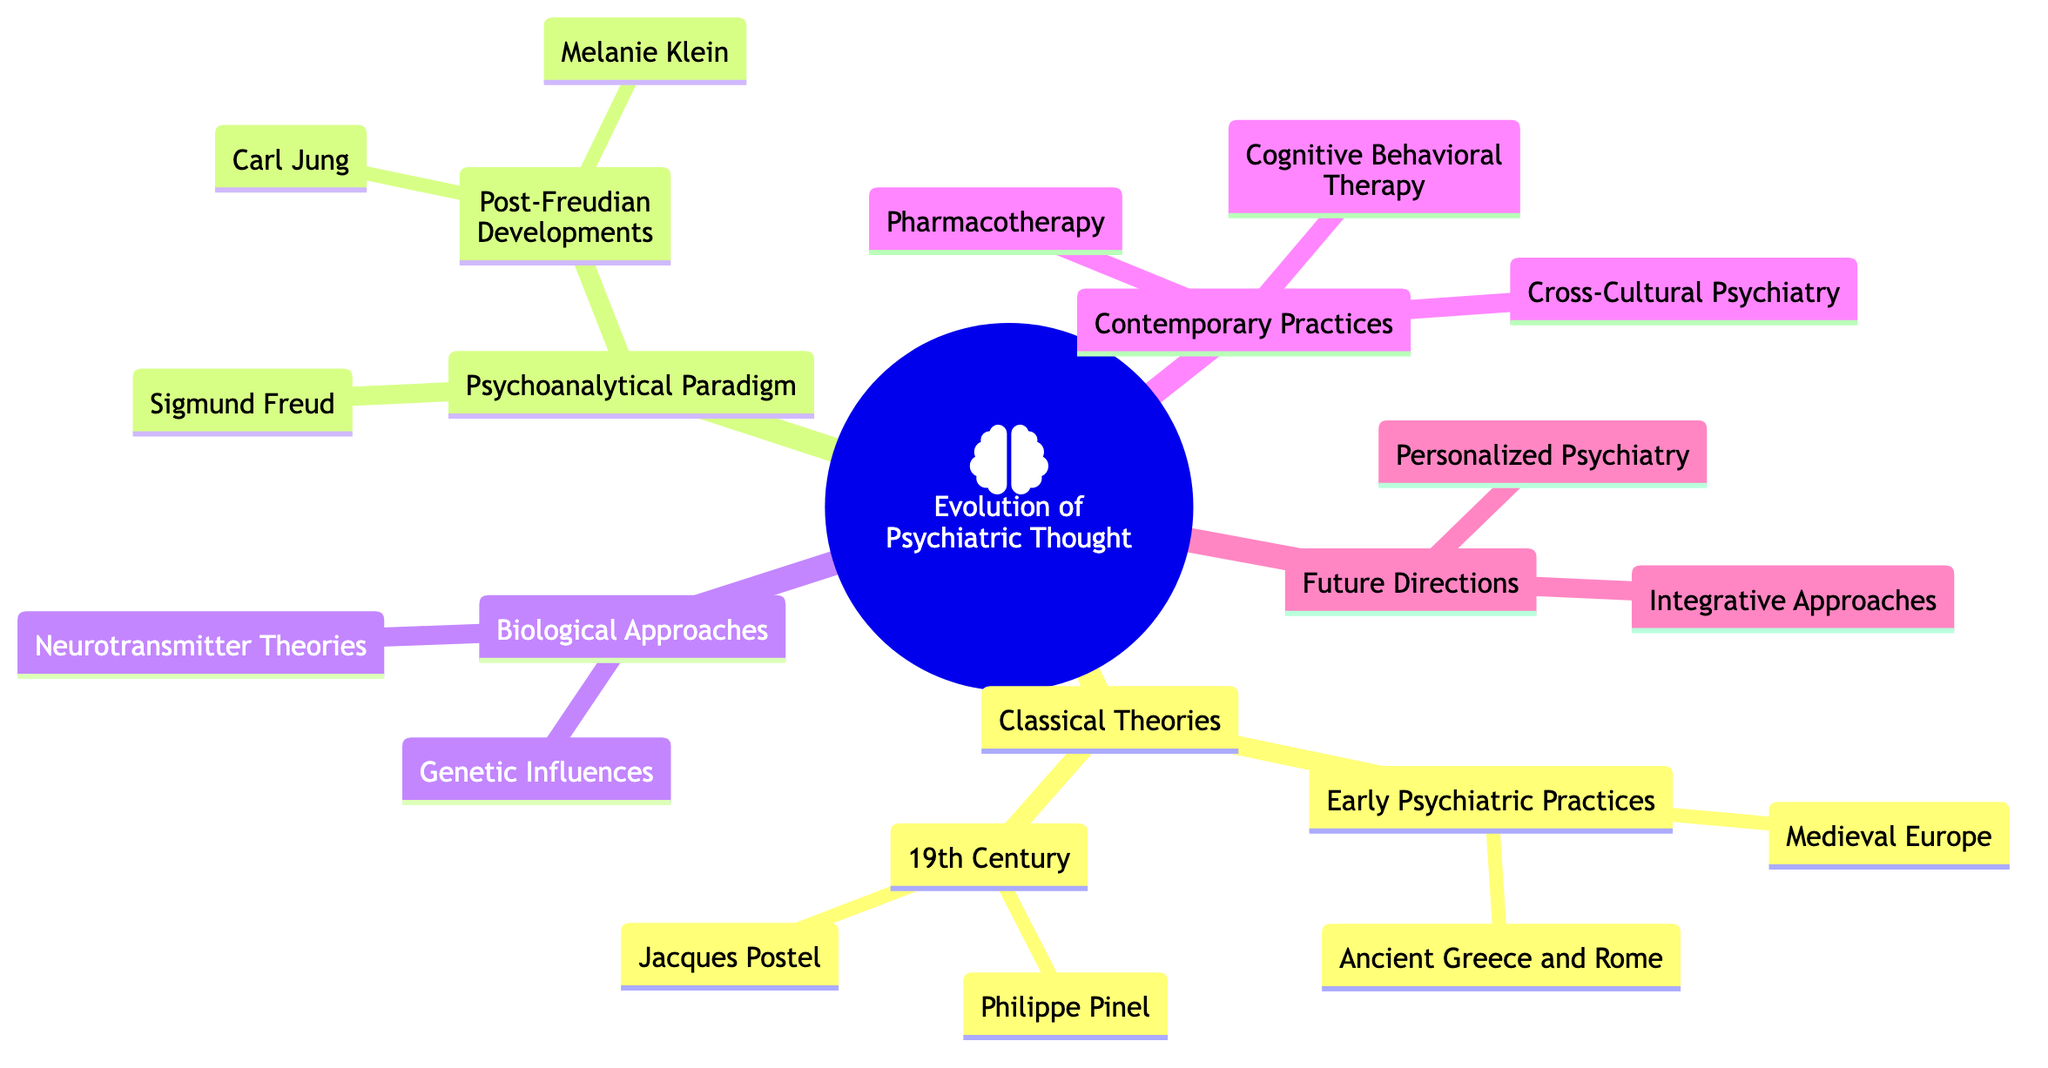What are the two main divisions of the mind map? The main divisions as represented in the diagram are the 'Classical Theories' and 'Psychoanalytical Paradigm'. Each serves as a primary subtopic under the main topic of 'Evolution of Psychiatric Thought'.
Answer: Classical Theories, Psychoanalytical Paradigm How many elements are under the 'Contemporary Practices' subtopic? The 'Contemporary Practices' subtopic contains three elements: 'Cognitive Behavioral Therapy', 'Pharmacotherapy', and 'Cross-Cultural Psychiatry'. Therefore, there are three elements under this category.
Answer: 3 Who is associated with the 'Moral treatment' approach in the 19th century? In the mind map, 'Moral treatment' is directly linked to Philippe Pinel, who is noted for this approach during that period. Thus, Philippe Pinel is the answer.
Answer: Philippe Pinel Which approaches are listed under 'Future Directions'? The 'Future Directions' contains two approaches: 'Personalized Psychiatry' and 'Integrative Approaches'. Both are noted as significant trends for future evolutions in psychiatric thought.
Answer: Personalized Psychiatry, Integrative Approaches What theory focuses on the 'unconscious mind'? The mind map shows that Sigmund Freud is associated with the theory that emphasizes the 'unconscious mind' as a central element of psychoanalysis. Thus, Freud is the answer.
Answer: Sigmund Freud Which element appears under the 'Biological Approaches' subtopic that pertains to mental illness? 'Neurotransmitter Theories' is the element described under the 'Biological Approaches' that relates to the role of serotonin and dopamine in mental illness. Therefore, this is the answer.
Answer: Neurotransmitter Theories What is a common theme across the subtopics in the mind map? A common theme across the subtopics is the progression of understanding mental health, moving from historical perspectives to contemporary practices and future innovations, signaling a continuous evolution in psychiatric thought.
Answer: Evolution of understanding How are Jacques Postel's contributions categorized in the history of psychiatric thought? Jacques Postel's contributions are part of the '19th Century' section under 'Classical Theories', specifically highlighting his critical approaches within the historical context of psychiatry.
Answer: 19th Century, Classical Theories 